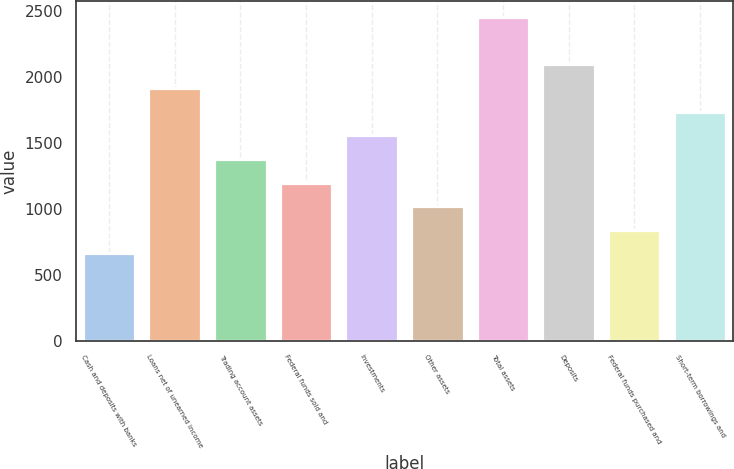<chart> <loc_0><loc_0><loc_500><loc_500><bar_chart><fcel>Cash and deposits with banks<fcel>Loans net of unearned income<fcel>Trading account assets<fcel>Federal funds sold and<fcel>Investments<fcel>Other assets<fcel>Total assets<fcel>Deposits<fcel>Federal funds purchased and<fcel>Short-term borrowings and<nl><fcel>661<fcel>1914<fcel>1377<fcel>1198<fcel>1556<fcel>1019<fcel>2451<fcel>2093<fcel>840<fcel>1735<nl></chart> 